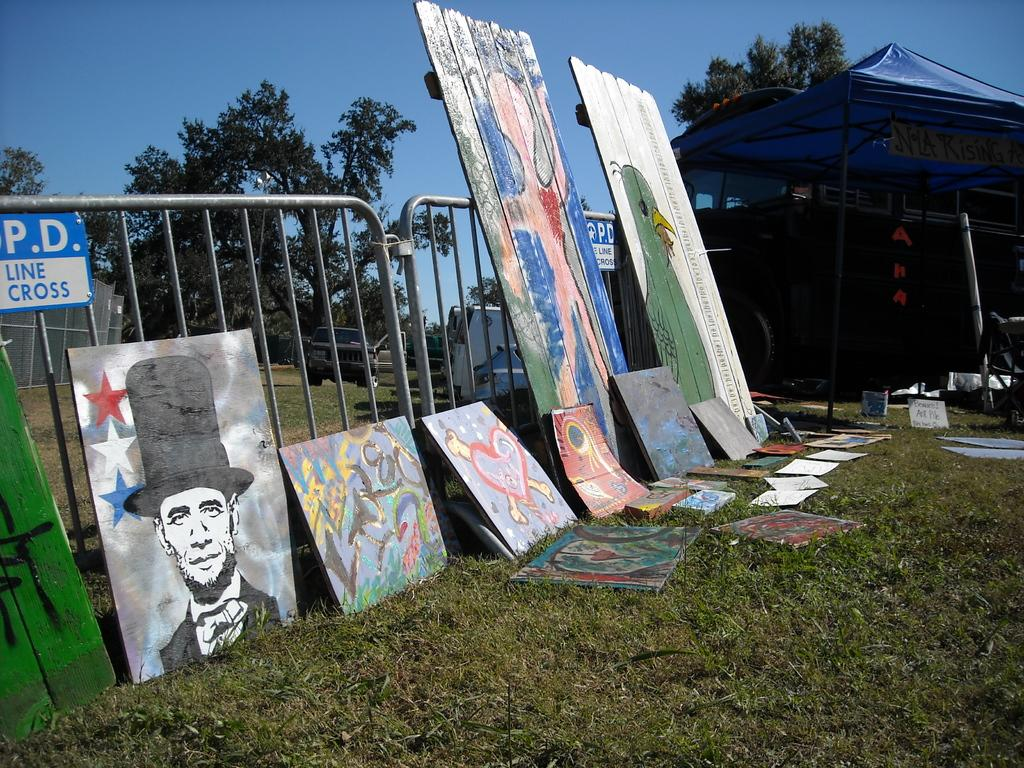What is depicted on the boards in the image? There are paintings on boards in the image. Where are the boards with paintings located? The boards are on the grass. What type of structure can be seen in the image? There is a tent with iron poles in the image. What cooking equipment is present in the image? Iron grills are present in the image. What mode of transportation is visible in the image? There is a car in the image. What natural elements can be seen in the image? Trees and the sky are visible in the image. How does the crowd affect the visibility of the paintings in the image? There is no crowd present in the image, so it does not affect the visibility of the paintings. What type of request can be made to the fog in the image? There is no fog present in the image, so no request can be made to it. 